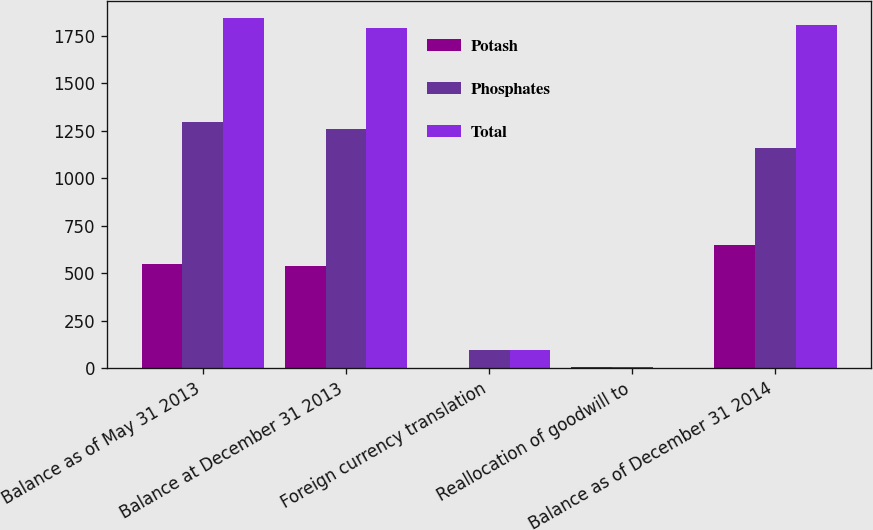<chart> <loc_0><loc_0><loc_500><loc_500><stacked_bar_chart><ecel><fcel>Balance as of May 31 2013<fcel>Balance at December 31 2013<fcel>Foreign currency translation<fcel>Reallocation of goodwill to<fcel>Balance as of December 31 2014<nl><fcel>Potash<fcel>546.6<fcel>535.8<fcel>1.6<fcel>5.1<fcel>648.4<nl><fcel>Phosphates<fcel>1298<fcel>1258.6<fcel>95.7<fcel>4.8<fcel>1158.1<nl><fcel>Total<fcel>1844.6<fcel>1794.4<fcel>94.1<fcel>0.3<fcel>1806.5<nl></chart> 